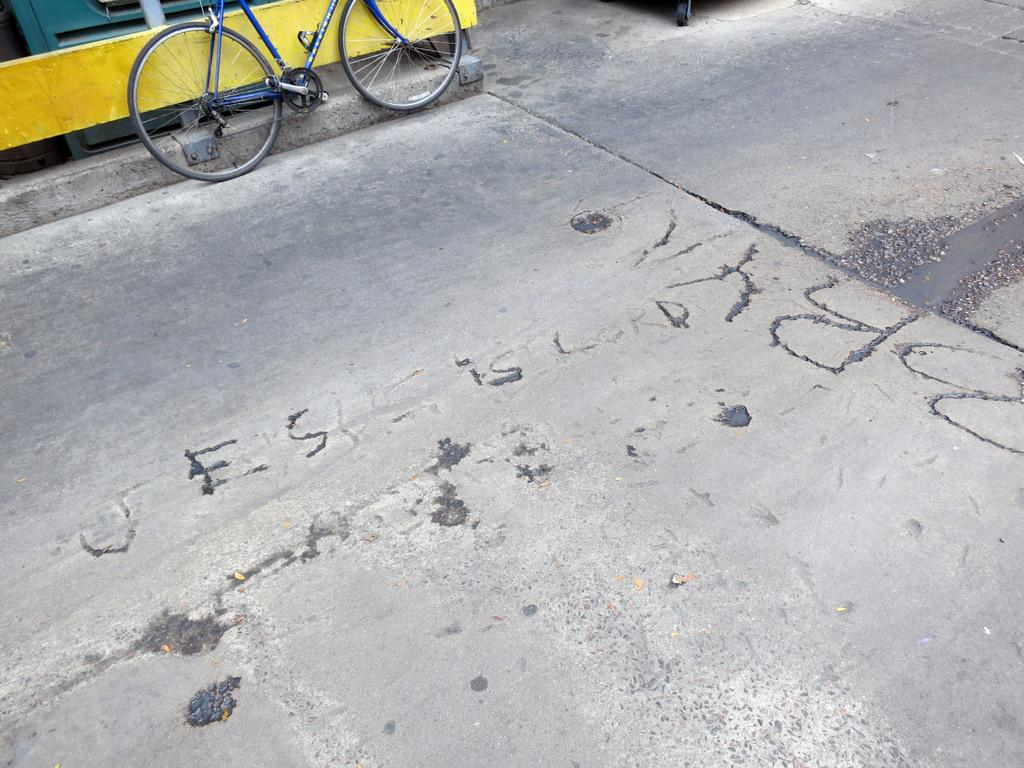What type of surface is shown in the image? There is a path surface in the image. Can you identify any objects related to transportation in the image? Yes, a part of a bicycle is visible in the image. Where is the bicycle located in relation to other objects? The bicycle is parked near a yellow color railing. Who is the passenger waiting for near the bicycle in the image? There is no passenger or waiting person present in the image. 